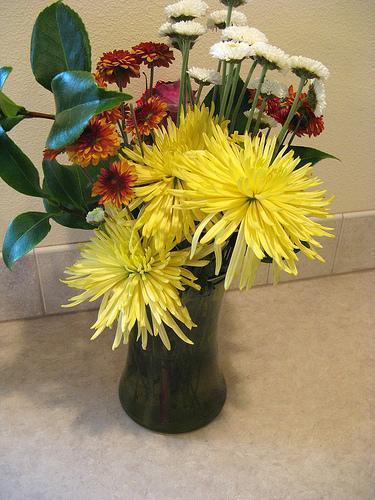How many vases are there?
Give a very brief answer. 1. 